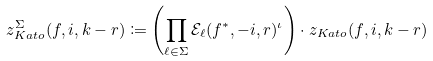<formula> <loc_0><loc_0><loc_500><loc_500>z ^ { \Sigma } _ { K a t o } ( f , i , k - r ) & \coloneqq \left ( \prod _ { \ell \in \Sigma } \mathcal { E } _ { \ell } ( f ^ { * } , - i , r ) ^ { \iota } \right ) \cdot z _ { K a t o } ( f , i , k - r )</formula> 